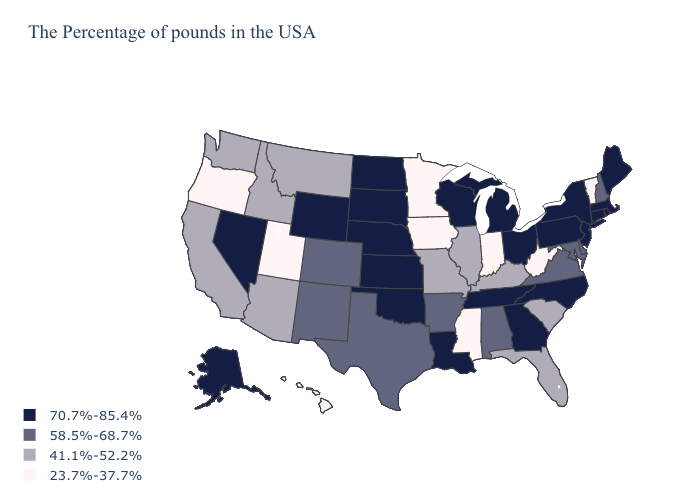Does Oregon have the lowest value in the USA?
Keep it brief. Yes. Is the legend a continuous bar?
Quick response, please. No. What is the value of Florida?
Answer briefly. 41.1%-52.2%. Which states have the lowest value in the Northeast?
Write a very short answer. Vermont. Name the states that have a value in the range 41.1%-52.2%?
Give a very brief answer. South Carolina, Florida, Kentucky, Illinois, Missouri, Montana, Arizona, Idaho, California, Washington. Which states have the lowest value in the Northeast?
Quick response, please. Vermont. Which states have the highest value in the USA?
Write a very short answer. Maine, Massachusetts, Rhode Island, Connecticut, New York, New Jersey, Pennsylvania, North Carolina, Ohio, Georgia, Michigan, Tennessee, Wisconsin, Louisiana, Kansas, Nebraska, Oklahoma, South Dakota, North Dakota, Wyoming, Nevada, Alaska. Which states hav the highest value in the South?
Quick response, please. North Carolina, Georgia, Tennessee, Louisiana, Oklahoma. Does Wyoming have the highest value in the West?
Write a very short answer. Yes. Among the states that border North Dakota , does Minnesota have the lowest value?
Concise answer only. Yes. Does the map have missing data?
Write a very short answer. No. Which states hav the highest value in the West?
Keep it brief. Wyoming, Nevada, Alaska. Which states have the highest value in the USA?
Be succinct. Maine, Massachusetts, Rhode Island, Connecticut, New York, New Jersey, Pennsylvania, North Carolina, Ohio, Georgia, Michigan, Tennessee, Wisconsin, Louisiana, Kansas, Nebraska, Oklahoma, South Dakota, North Dakota, Wyoming, Nevada, Alaska. What is the highest value in the Northeast ?
Be succinct. 70.7%-85.4%. 